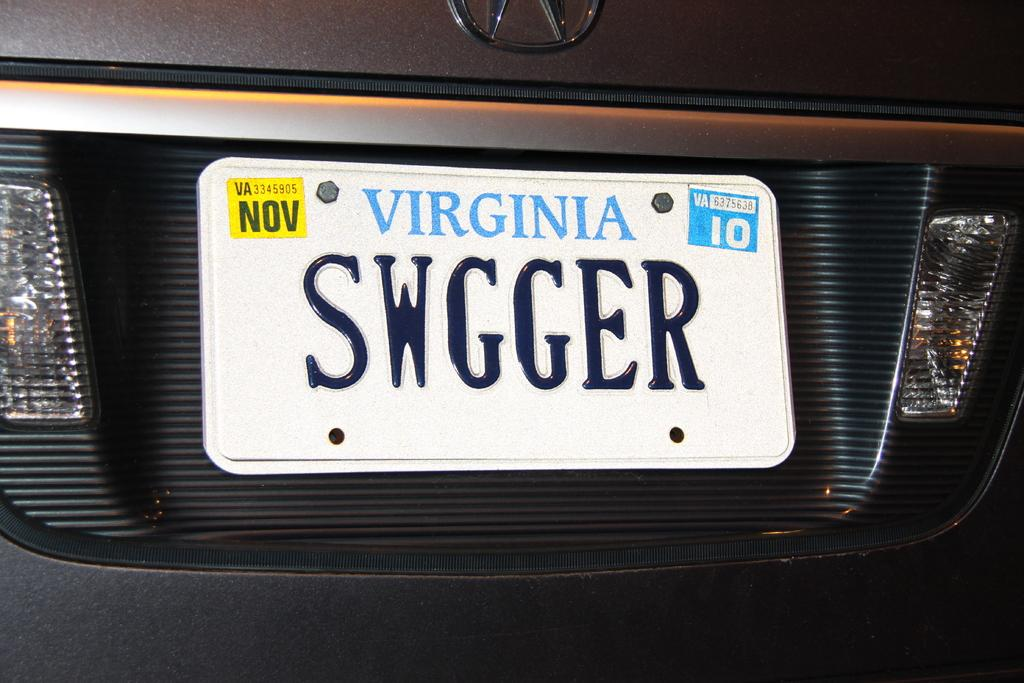<image>
Relay a brief, clear account of the picture shown. A car registered in the state of Virginia. 